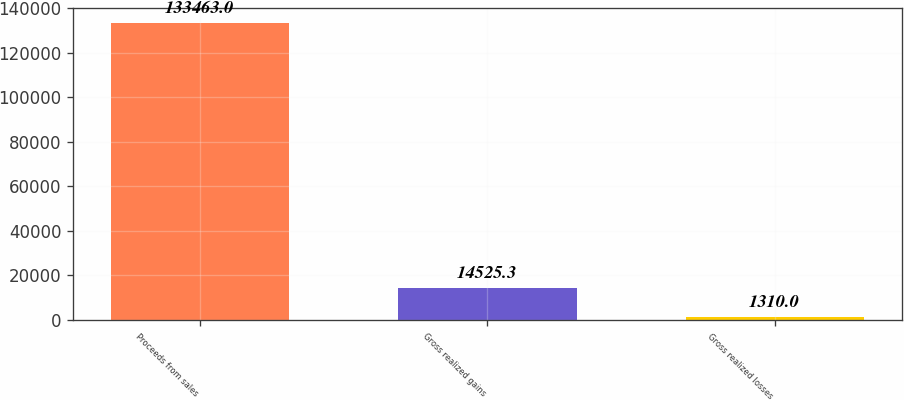<chart> <loc_0><loc_0><loc_500><loc_500><bar_chart><fcel>Proceeds from sales<fcel>Gross realized gains<fcel>Gross realized losses<nl><fcel>133463<fcel>14525.3<fcel>1310<nl></chart> 